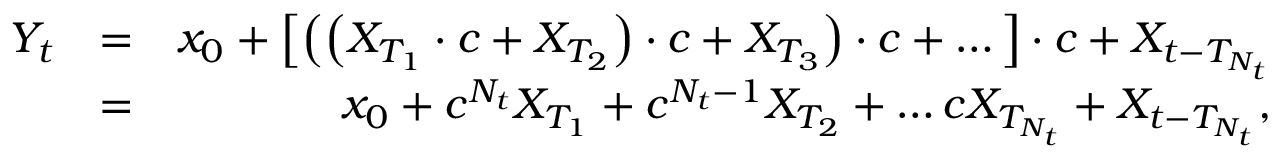Convert formula to latex. <formula><loc_0><loc_0><loc_500><loc_500>\begin{array} { r l r } { Y _ { t } } & { = } & { x _ { 0 } + \left [ \left ( \left ( X _ { T _ { 1 } } \cdot c + X _ { T _ { 2 } } \right ) \cdot c + X _ { T _ { 3 } } \right ) \cdot c + \dots \right ] \cdot c + X _ { t - T _ { N _ { t } } } } \\ & { = } & { x _ { 0 } + c ^ { N _ { t } } X _ { T _ { 1 } } + c ^ { N _ { t } - 1 } X _ { T _ { 2 } } + \dots c X _ { T _ { N _ { t } } } + X _ { t - T _ { N _ { t } } } , } \end{array}</formula> 